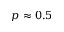Convert formula to latex. <formula><loc_0><loc_0><loc_500><loc_500>p \approx 0 . 5</formula> 